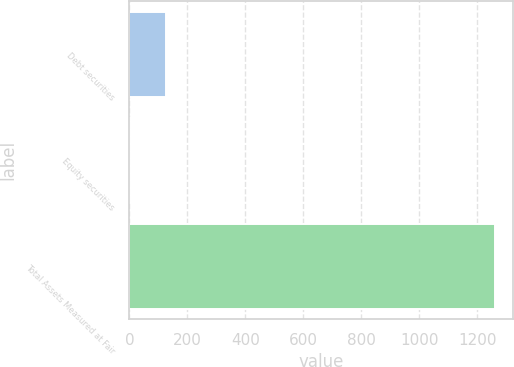<chart> <loc_0><loc_0><loc_500><loc_500><bar_chart><fcel>Debt securities<fcel>Equity securities<fcel>Total Assets Measured at Fair<nl><fcel>126.64<fcel>0.6<fcel>1261<nl></chart> 